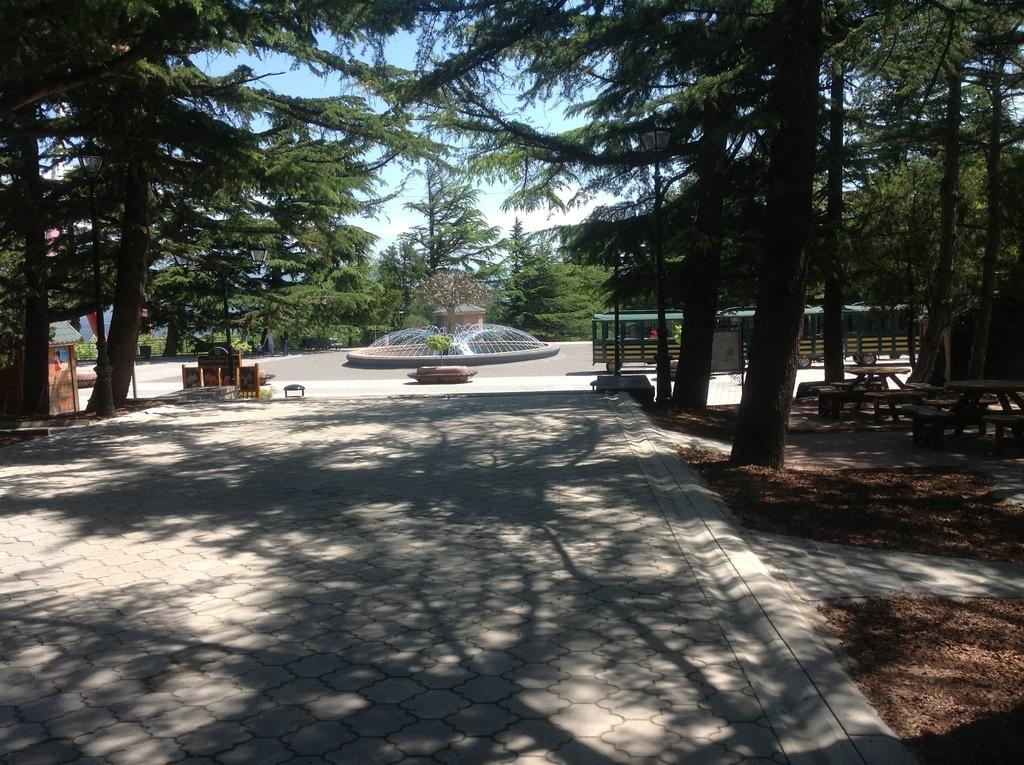What is the main feature of the image? There is a road in the image. What can be found alongside the road? There are benches on the ground. What other structures are present in the image? There are boards and light poles in the image. What is a unique feature in the image? There is a fountain in the image. What natural element is visible in the image? There is water visible in the image. Are there any plants in the image? Yes, there is a plant in the image. What type of transportation can be seen in the image? There are vehicles in the image. What additional objects are present in the image? There are some objects in the image. What can be seen in the background of the image? There are trees and the sky visible in the background of the image. How many cows are grazing near the fountain in the image? There are no cows present in the image; it features a road, benches, boards, light poles, a fountain, water, a plant, vehicles, and additional objects. 